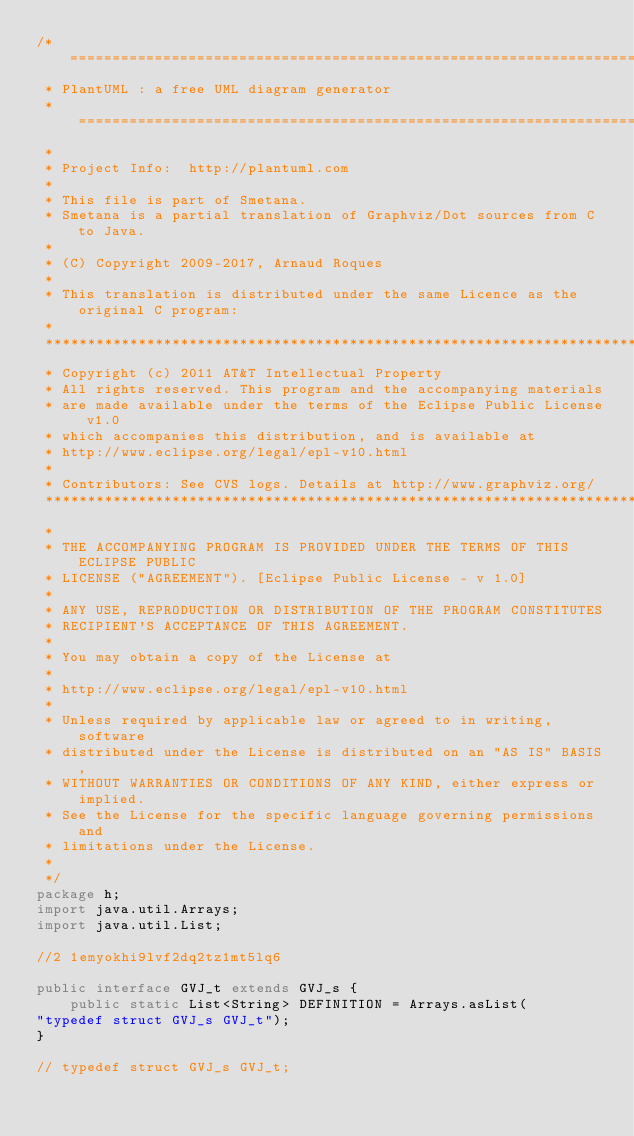Convert code to text. <code><loc_0><loc_0><loc_500><loc_500><_Java_>/* ========================================================================
 * PlantUML : a free UML diagram generator
 * ========================================================================
 *
 * Project Info:  http://plantuml.com
 * 
 * This file is part of Smetana.
 * Smetana is a partial translation of Graphviz/Dot sources from C to Java.
 *
 * (C) Copyright 2009-2017, Arnaud Roques
 *
 * This translation is distributed under the same Licence as the original C program:
 * 
 *************************************************************************
 * Copyright (c) 2011 AT&T Intellectual Property 
 * All rights reserved. This program and the accompanying materials
 * are made available under the terms of the Eclipse Public License v1.0
 * which accompanies this distribution, and is available at
 * http://www.eclipse.org/legal/epl-v10.html
 *
 * Contributors: See CVS logs. Details at http://www.graphviz.org/
 *************************************************************************
 *
 * THE ACCOMPANYING PROGRAM IS PROVIDED UNDER THE TERMS OF THIS ECLIPSE PUBLIC
 * LICENSE ("AGREEMENT"). [Eclipse Public License - v 1.0]
 * 
 * ANY USE, REPRODUCTION OR DISTRIBUTION OF THE PROGRAM CONSTITUTES
 * RECIPIENT'S ACCEPTANCE OF THIS AGREEMENT.
 * 
 * You may obtain a copy of the License at
 * 
 * http://www.eclipse.org/legal/epl-v10.html
 * 
 * Unless required by applicable law or agreed to in writing, software
 * distributed under the License is distributed on an "AS IS" BASIS,
 * WITHOUT WARRANTIES OR CONDITIONS OF ANY KIND, either express or implied.
 * See the License for the specific language governing permissions and
 * limitations under the License.
 *
 */
package h;
import java.util.Arrays;
import java.util.List;

//2 1emyokhi9lvf2dq2tz1mt5lq6

public interface GVJ_t extends GVJ_s {
	public static List<String> DEFINITION = Arrays.asList(
"typedef struct GVJ_s GVJ_t");
}

// typedef struct GVJ_s GVJ_t;</code> 